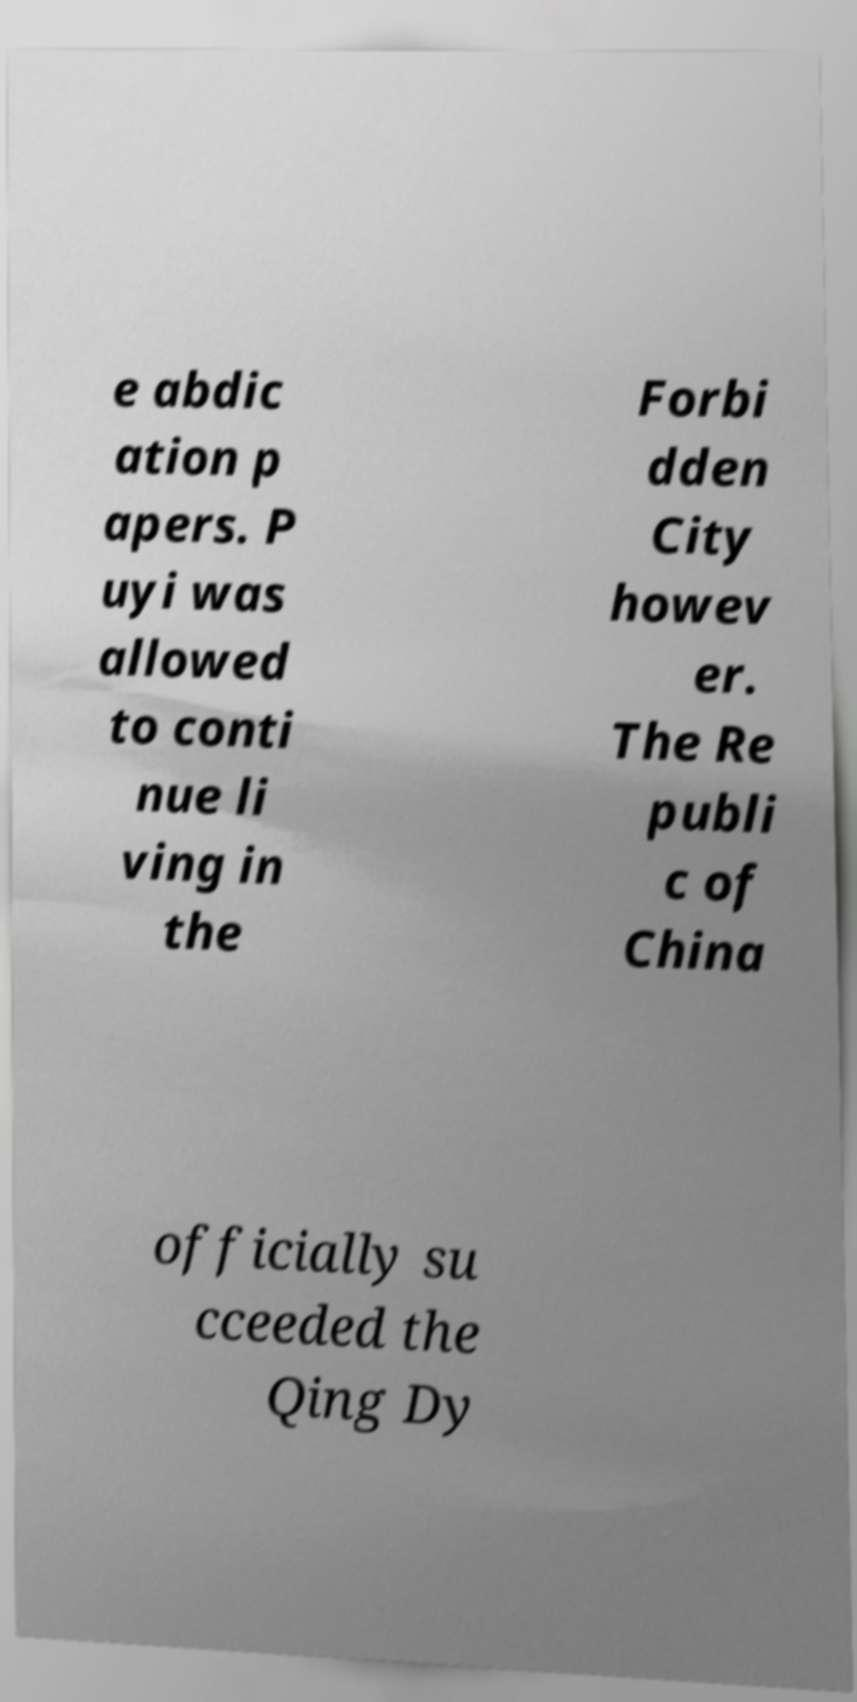Please identify and transcribe the text found in this image. e abdic ation p apers. P uyi was allowed to conti nue li ving in the Forbi dden City howev er. The Re publi c of China officially su cceeded the Qing Dy 